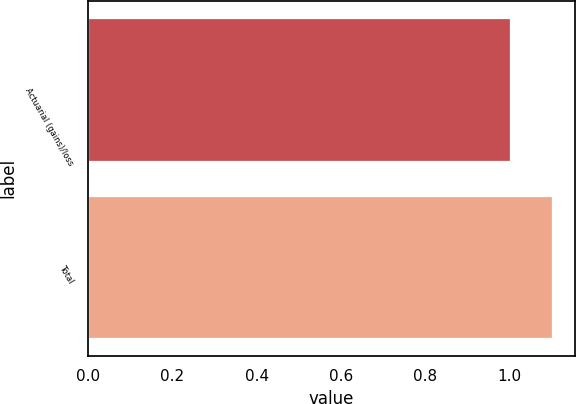Convert chart. <chart><loc_0><loc_0><loc_500><loc_500><bar_chart><fcel>Actuarial (gains)/loss<fcel>Total<nl><fcel>1<fcel>1.1<nl></chart> 